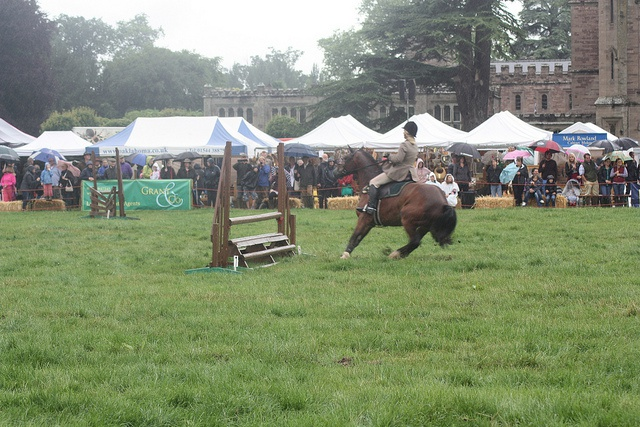Describe the objects in this image and their specific colors. I can see people in gray, darkgray, black, and olive tones, umbrella in gray, white, lavender, and darkgray tones, horse in gray and black tones, people in gray, darkgray, and lightgray tones, and umbrella in gray, white, and darkgray tones in this image. 